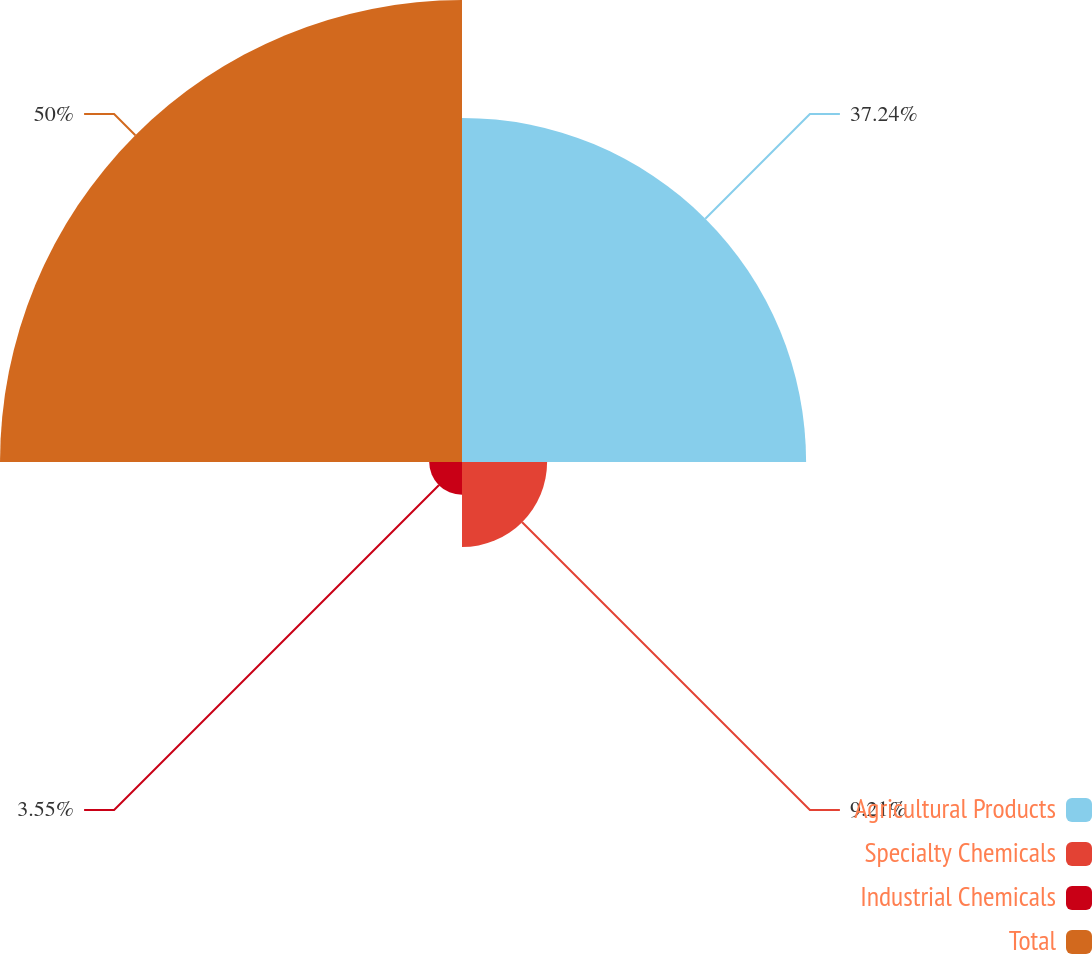Convert chart. <chart><loc_0><loc_0><loc_500><loc_500><pie_chart><fcel>Agricultural Products<fcel>Specialty Chemicals<fcel>Industrial Chemicals<fcel>Total<nl><fcel>37.24%<fcel>9.21%<fcel>3.55%<fcel>50.0%<nl></chart> 